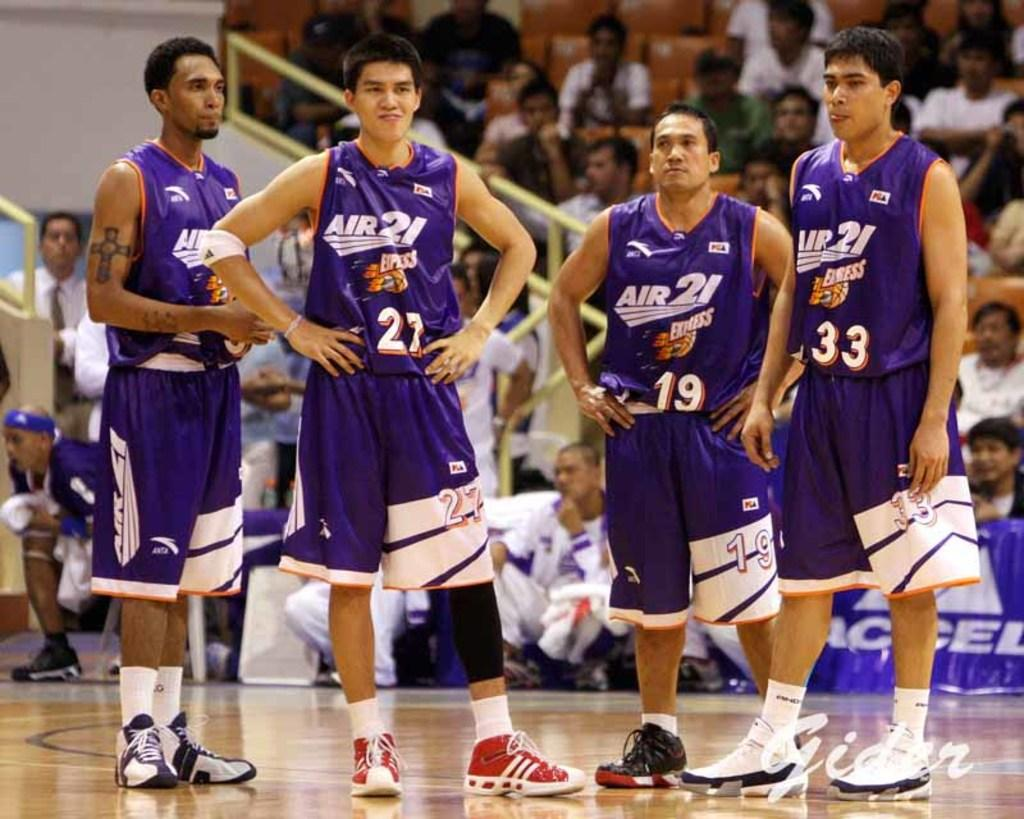<image>
Give a short and clear explanation of the subsequent image. 4 men with jerseys that say air 21 